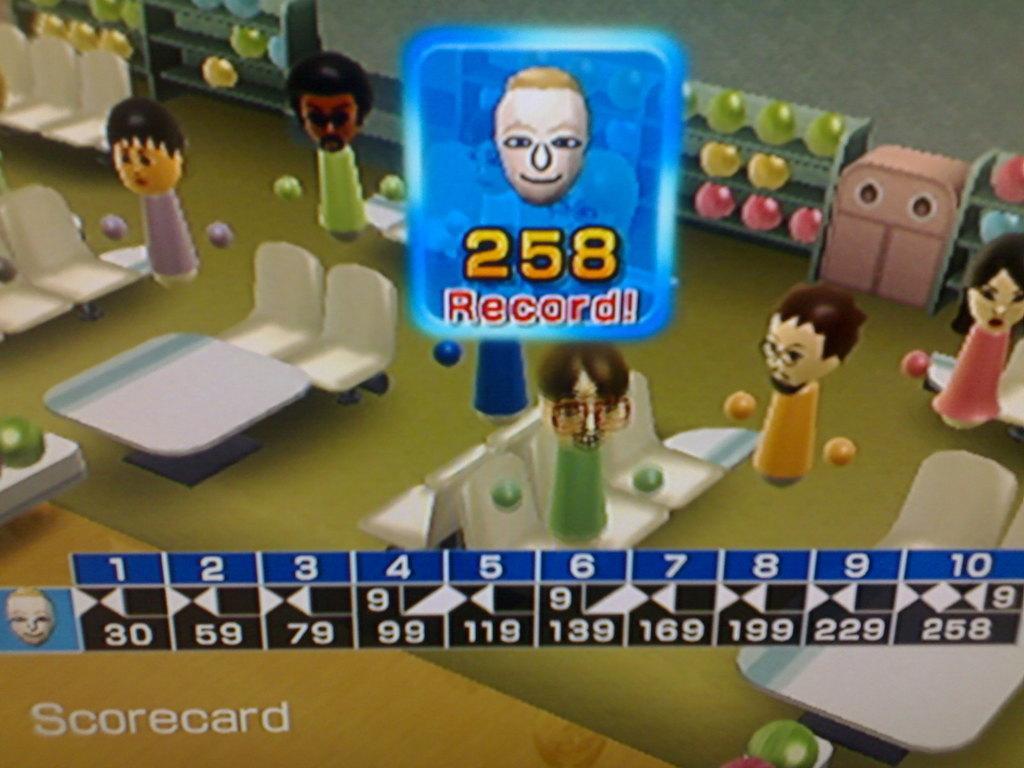Describe this image in one or two sentences. In this picture we can see the view of the cartoon gaming screen. In the front we can see the scoreboard and some dolls sitting on the chairs. 